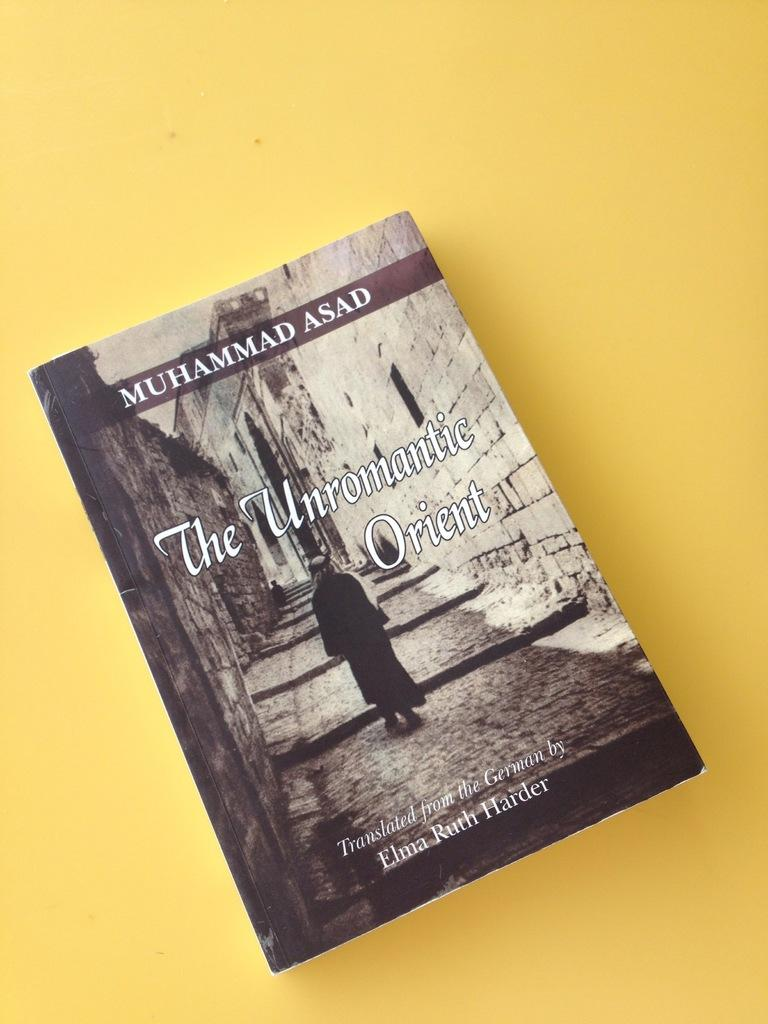<image>
Describe the image concisely. A book cover that was translated from German. 